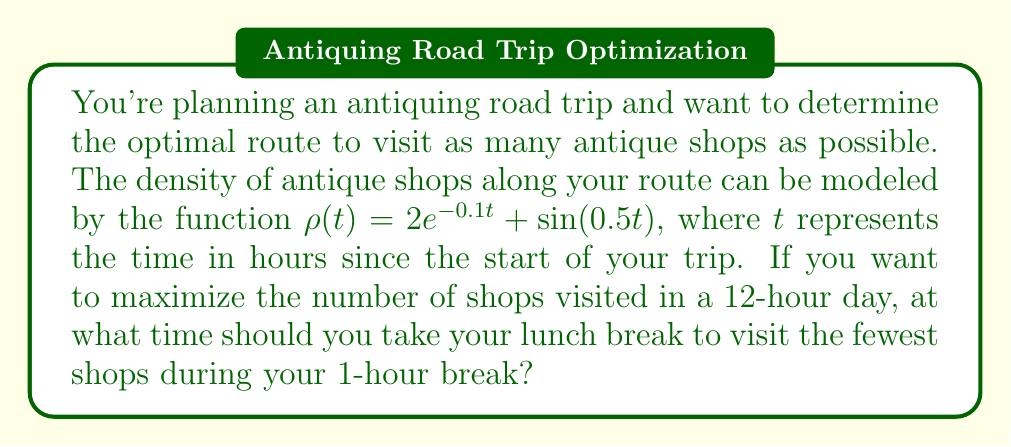Can you answer this question? To solve this problem, we need to find the minimum point of the antique shop density function within the given 12-hour period. This will ensure that we visit the fewest shops during our 1-hour lunch break.

1. The density function is given by:
   $$\rho(t) = 2e^{-0.1t} + \sin(0.5t)$$

2. To find the minimum point, we need to find where the derivative of $\rho(t)$ equals zero:
   $$\frac{d\rho}{dt} = -0.2e^{-0.1t} + 0.5\cos(0.5t)$$

3. Set the derivative equal to zero:
   $$-0.2e^{-0.1t} + 0.5\cos(0.5t) = 0$$

4. This equation cannot be solved analytically, so we need to use numerical methods. We can use a root-finding algorithm like Newton's method or simply plot the function and visually identify the minimum points.

5. Using a plotting tool, we can see that within the 12-hour period, there are two local minima:
   - One at approximately t = 3.8 hours
   - Another at approximately t = 10.4 hours

6. To determine which of these is the global minimum within our time frame, we evaluate $\rho(t)$ at both points:
   $$\rho(3.8) \approx 1.37$$
   $$\rho(10.4) \approx 1.13$$

7. The global minimum occurs at t ≈ 10.4 hours, which corresponds to about 10 hours and 24 minutes into the trip.
Answer: The optimal time to take the 1-hour lunch break is approximately 10 hours and 24 minutes after the start of the trip. 